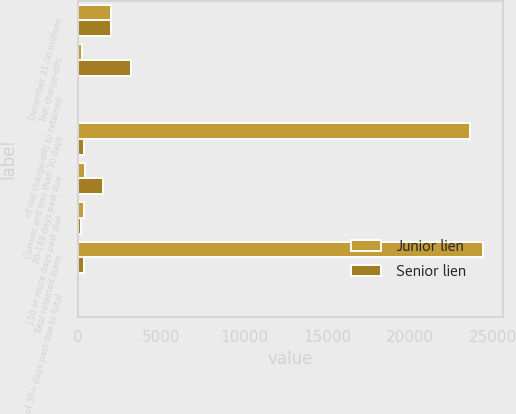Convert chart. <chart><loc_0><loc_0><loc_500><loc_500><stacked_bar_chart><ecel><fcel>December 31 (in millions<fcel>Net charge-offs<fcel>of net charge-offs to retained<fcel>Current and less than 30 days<fcel>30-149 days past due<fcel>150 or more days past due<fcel>Total retained loans<fcel>of 30+ days past due to total<nl><fcel>Junior lien<fcel>2010<fcel>262<fcel>1<fcel>23615<fcel>414<fcel>347<fcel>24376<fcel>3.12<nl><fcel>Senior lien<fcel>2010<fcel>3182<fcel>4.63<fcel>380.5<fcel>1508<fcel>186<fcel>380.5<fcel>2.65<nl></chart> 